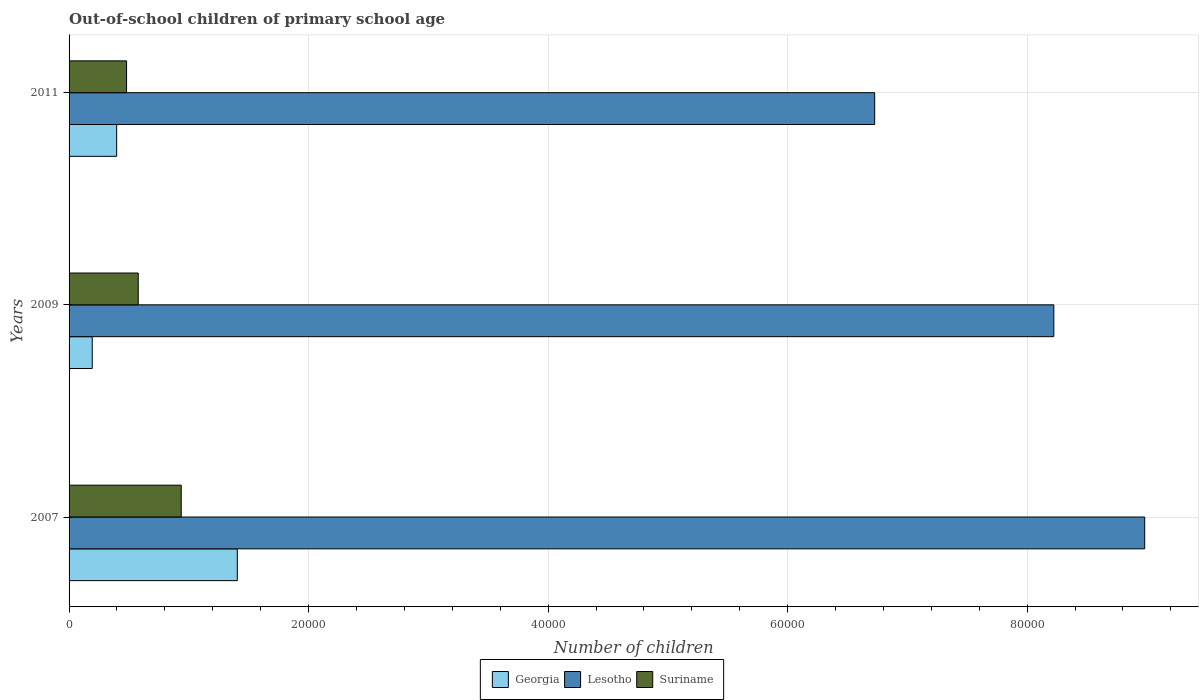Are the number of bars per tick equal to the number of legend labels?
Make the answer very short. Yes. In how many cases, is the number of bars for a given year not equal to the number of legend labels?
Ensure brevity in your answer.  0. What is the number of out-of-school children in Georgia in 2007?
Ensure brevity in your answer.  1.40e+04. Across all years, what is the maximum number of out-of-school children in Suriname?
Your answer should be very brief. 9364. Across all years, what is the minimum number of out-of-school children in Lesotho?
Give a very brief answer. 6.73e+04. In which year was the number of out-of-school children in Georgia minimum?
Your answer should be compact. 2009. What is the total number of out-of-school children in Lesotho in the graph?
Provide a succinct answer. 2.39e+05. What is the difference between the number of out-of-school children in Georgia in 2007 and that in 2011?
Provide a succinct answer. 1.01e+04. What is the difference between the number of out-of-school children in Georgia in 2009 and the number of out-of-school children in Suriname in 2011?
Offer a very short reply. -2868. What is the average number of out-of-school children in Lesotho per year?
Provide a succinct answer. 7.98e+04. In the year 2009, what is the difference between the number of out-of-school children in Georgia and number of out-of-school children in Lesotho?
Provide a short and direct response. -8.03e+04. What is the ratio of the number of out-of-school children in Georgia in 2007 to that in 2011?
Your answer should be very brief. 3.53. Is the number of out-of-school children in Lesotho in 2009 less than that in 2011?
Keep it short and to the point. No. What is the difference between the highest and the second highest number of out-of-school children in Suriname?
Your answer should be compact. 3589. What is the difference between the highest and the lowest number of out-of-school children in Suriname?
Provide a succinct answer. 4562. In how many years, is the number of out-of-school children in Suriname greater than the average number of out-of-school children in Suriname taken over all years?
Provide a succinct answer. 1. Is the sum of the number of out-of-school children in Lesotho in 2007 and 2009 greater than the maximum number of out-of-school children in Georgia across all years?
Your answer should be very brief. Yes. What does the 2nd bar from the top in 2009 represents?
Keep it short and to the point. Lesotho. What does the 3rd bar from the bottom in 2007 represents?
Give a very brief answer. Suriname. Is it the case that in every year, the sum of the number of out-of-school children in Suriname and number of out-of-school children in Georgia is greater than the number of out-of-school children in Lesotho?
Give a very brief answer. No. What is the difference between two consecutive major ticks on the X-axis?
Your answer should be very brief. 2.00e+04. Does the graph contain any zero values?
Your response must be concise. No. Does the graph contain grids?
Keep it short and to the point. Yes. Where does the legend appear in the graph?
Ensure brevity in your answer.  Bottom center. What is the title of the graph?
Give a very brief answer. Out-of-school children of primary school age. Does "Upper middle income" appear as one of the legend labels in the graph?
Keep it short and to the point. No. What is the label or title of the X-axis?
Provide a short and direct response. Number of children. What is the Number of children of Georgia in 2007?
Make the answer very short. 1.40e+04. What is the Number of children in Lesotho in 2007?
Provide a short and direct response. 8.98e+04. What is the Number of children of Suriname in 2007?
Ensure brevity in your answer.  9364. What is the Number of children of Georgia in 2009?
Provide a succinct answer. 1934. What is the Number of children in Lesotho in 2009?
Ensure brevity in your answer.  8.22e+04. What is the Number of children in Suriname in 2009?
Your response must be concise. 5775. What is the Number of children of Georgia in 2011?
Give a very brief answer. 3975. What is the Number of children of Lesotho in 2011?
Offer a very short reply. 6.73e+04. What is the Number of children of Suriname in 2011?
Provide a succinct answer. 4802. Across all years, what is the maximum Number of children in Georgia?
Offer a terse response. 1.40e+04. Across all years, what is the maximum Number of children in Lesotho?
Provide a succinct answer. 8.98e+04. Across all years, what is the maximum Number of children of Suriname?
Give a very brief answer. 9364. Across all years, what is the minimum Number of children in Georgia?
Provide a succinct answer. 1934. Across all years, what is the minimum Number of children of Lesotho?
Provide a succinct answer. 6.73e+04. Across all years, what is the minimum Number of children of Suriname?
Keep it short and to the point. 4802. What is the total Number of children of Georgia in the graph?
Offer a very short reply. 2.00e+04. What is the total Number of children of Lesotho in the graph?
Give a very brief answer. 2.39e+05. What is the total Number of children of Suriname in the graph?
Your answer should be compact. 1.99e+04. What is the difference between the Number of children in Georgia in 2007 and that in 2009?
Provide a short and direct response. 1.21e+04. What is the difference between the Number of children in Lesotho in 2007 and that in 2009?
Offer a very short reply. 7589. What is the difference between the Number of children in Suriname in 2007 and that in 2009?
Offer a very short reply. 3589. What is the difference between the Number of children in Georgia in 2007 and that in 2011?
Your answer should be very brief. 1.01e+04. What is the difference between the Number of children of Lesotho in 2007 and that in 2011?
Offer a terse response. 2.25e+04. What is the difference between the Number of children in Suriname in 2007 and that in 2011?
Make the answer very short. 4562. What is the difference between the Number of children of Georgia in 2009 and that in 2011?
Ensure brevity in your answer.  -2041. What is the difference between the Number of children of Lesotho in 2009 and that in 2011?
Make the answer very short. 1.50e+04. What is the difference between the Number of children in Suriname in 2009 and that in 2011?
Make the answer very short. 973. What is the difference between the Number of children in Georgia in 2007 and the Number of children in Lesotho in 2009?
Provide a succinct answer. -6.82e+04. What is the difference between the Number of children in Georgia in 2007 and the Number of children in Suriname in 2009?
Your response must be concise. 8272. What is the difference between the Number of children in Lesotho in 2007 and the Number of children in Suriname in 2009?
Offer a very short reply. 8.40e+04. What is the difference between the Number of children of Georgia in 2007 and the Number of children of Lesotho in 2011?
Provide a short and direct response. -5.32e+04. What is the difference between the Number of children of Georgia in 2007 and the Number of children of Suriname in 2011?
Offer a very short reply. 9245. What is the difference between the Number of children of Lesotho in 2007 and the Number of children of Suriname in 2011?
Make the answer very short. 8.50e+04. What is the difference between the Number of children in Georgia in 2009 and the Number of children in Lesotho in 2011?
Your response must be concise. -6.53e+04. What is the difference between the Number of children in Georgia in 2009 and the Number of children in Suriname in 2011?
Offer a terse response. -2868. What is the difference between the Number of children in Lesotho in 2009 and the Number of children in Suriname in 2011?
Your answer should be compact. 7.74e+04. What is the average Number of children of Georgia per year?
Your answer should be compact. 6652. What is the average Number of children in Lesotho per year?
Your answer should be compact. 7.98e+04. What is the average Number of children of Suriname per year?
Your answer should be compact. 6647. In the year 2007, what is the difference between the Number of children in Georgia and Number of children in Lesotho?
Provide a short and direct response. -7.58e+04. In the year 2007, what is the difference between the Number of children of Georgia and Number of children of Suriname?
Ensure brevity in your answer.  4683. In the year 2007, what is the difference between the Number of children of Lesotho and Number of children of Suriname?
Keep it short and to the point. 8.05e+04. In the year 2009, what is the difference between the Number of children of Georgia and Number of children of Lesotho?
Offer a terse response. -8.03e+04. In the year 2009, what is the difference between the Number of children of Georgia and Number of children of Suriname?
Keep it short and to the point. -3841. In the year 2009, what is the difference between the Number of children in Lesotho and Number of children in Suriname?
Ensure brevity in your answer.  7.65e+04. In the year 2011, what is the difference between the Number of children in Georgia and Number of children in Lesotho?
Keep it short and to the point. -6.33e+04. In the year 2011, what is the difference between the Number of children in Georgia and Number of children in Suriname?
Offer a terse response. -827. In the year 2011, what is the difference between the Number of children in Lesotho and Number of children in Suriname?
Your answer should be compact. 6.25e+04. What is the ratio of the Number of children of Georgia in 2007 to that in 2009?
Give a very brief answer. 7.26. What is the ratio of the Number of children of Lesotho in 2007 to that in 2009?
Give a very brief answer. 1.09. What is the ratio of the Number of children in Suriname in 2007 to that in 2009?
Provide a short and direct response. 1.62. What is the ratio of the Number of children of Georgia in 2007 to that in 2011?
Provide a succinct answer. 3.53. What is the ratio of the Number of children of Lesotho in 2007 to that in 2011?
Give a very brief answer. 1.34. What is the ratio of the Number of children of Suriname in 2007 to that in 2011?
Ensure brevity in your answer.  1.95. What is the ratio of the Number of children in Georgia in 2009 to that in 2011?
Ensure brevity in your answer.  0.49. What is the ratio of the Number of children in Lesotho in 2009 to that in 2011?
Provide a short and direct response. 1.22. What is the ratio of the Number of children of Suriname in 2009 to that in 2011?
Your answer should be very brief. 1.2. What is the difference between the highest and the second highest Number of children in Georgia?
Provide a short and direct response. 1.01e+04. What is the difference between the highest and the second highest Number of children in Lesotho?
Ensure brevity in your answer.  7589. What is the difference between the highest and the second highest Number of children in Suriname?
Provide a succinct answer. 3589. What is the difference between the highest and the lowest Number of children in Georgia?
Provide a short and direct response. 1.21e+04. What is the difference between the highest and the lowest Number of children in Lesotho?
Keep it short and to the point. 2.25e+04. What is the difference between the highest and the lowest Number of children in Suriname?
Your response must be concise. 4562. 